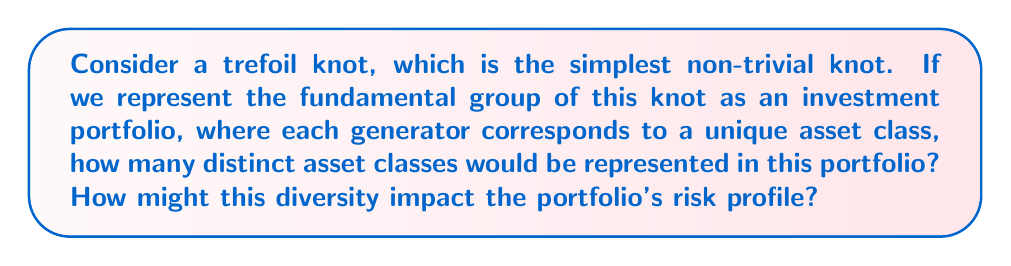Can you answer this question? To solve this problem, let's break it down step-by-step:

1) First, we need to understand the fundamental group of a trefoil knot:
   The fundamental group of a trefoil knot is given by the presentation:
   $$\pi_1(K) = \langle a, b \mid aba = bab \rangle$$

2) In this presentation, we have two generators: $a$ and $b$. These generators cannot be reduced to a single element due to the relation $aba = bab$.

3) Interpreting this in financial terms:
   - Each generator represents a distinct asset class in our investment portfolio.
   - The relation $aba = bab$ suggests these asset classes are interrelated but cannot be completely substituted for each other.

4) Therefore, this portfolio would consist of 2 distinct asset classes.

5) Impact on risk profile:
   - Having two distinct asset classes implies some level of diversification.
   - However, the complex relation between these assets (represented by $aba = bab$) suggests they may not provide complete independence in terms of risk.
   - This limited diversification could provide some risk mitigation compared to a single-asset portfolio, but may not offer as much protection as a more broadly diversified portfolio.

6) In financial terms, this could be analogous to a portfolio split between two related but distinct sectors, such as technology hardware and software. They're interconnected but not identical in their risk profiles.
Answer: 2 asset classes; moderately reduced risk through limited diversification 